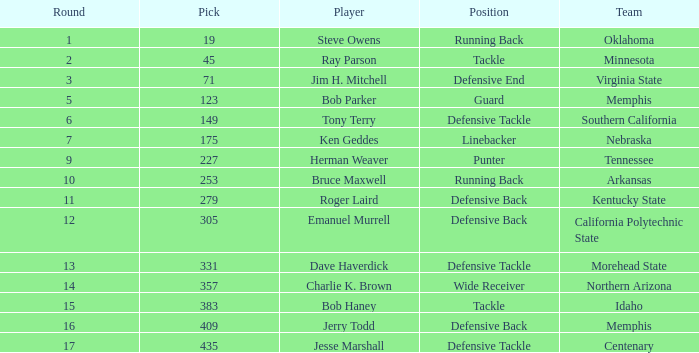What is the average pick of player jim h. mitchell? 71.0. 